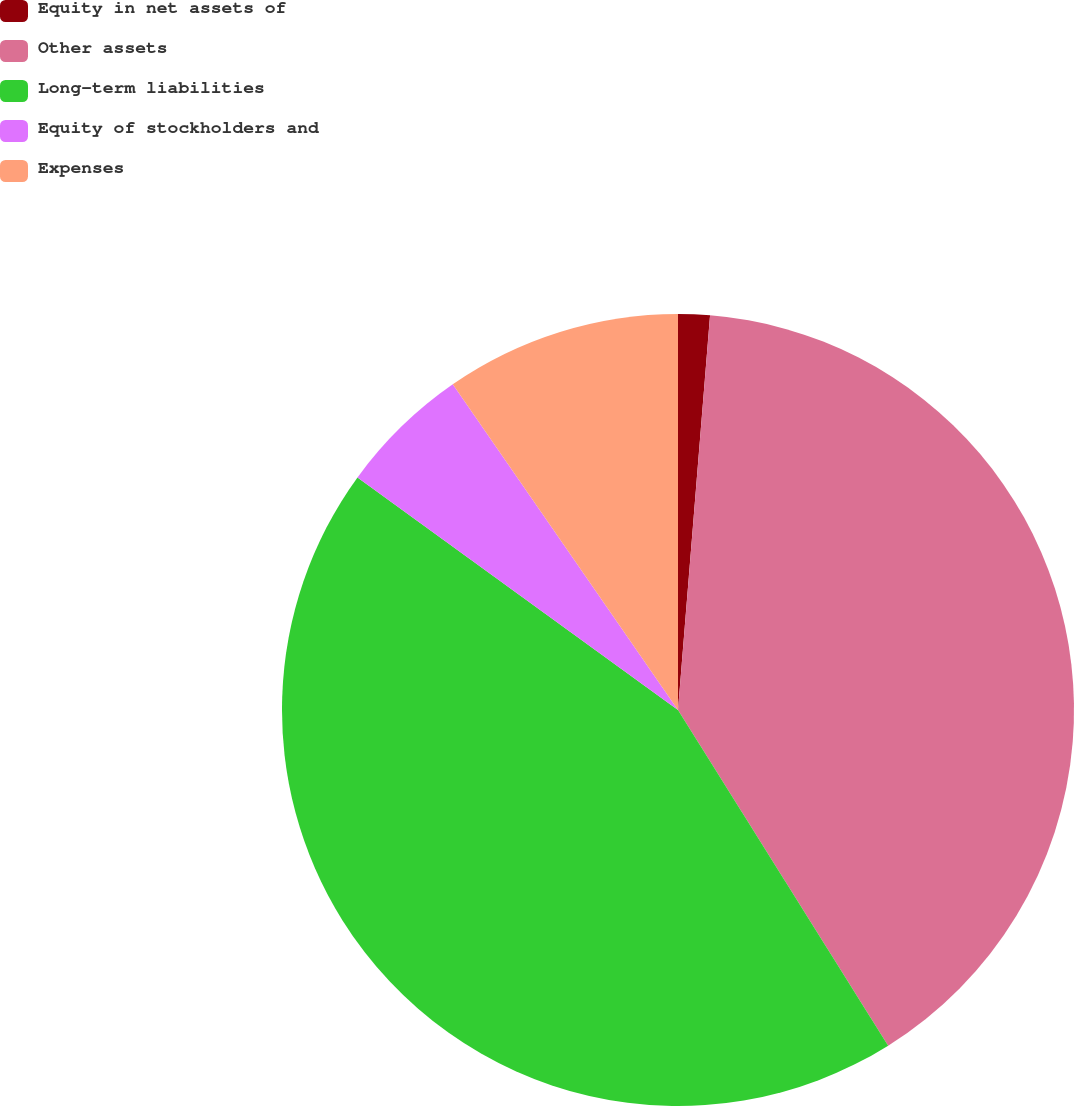Convert chart to OTSL. <chart><loc_0><loc_0><loc_500><loc_500><pie_chart><fcel>Equity in net assets of<fcel>Other assets<fcel>Long-term liabilities<fcel>Equity of stockholders and<fcel>Expenses<nl><fcel>1.29%<fcel>39.81%<fcel>43.9%<fcel>5.38%<fcel>9.63%<nl></chart> 